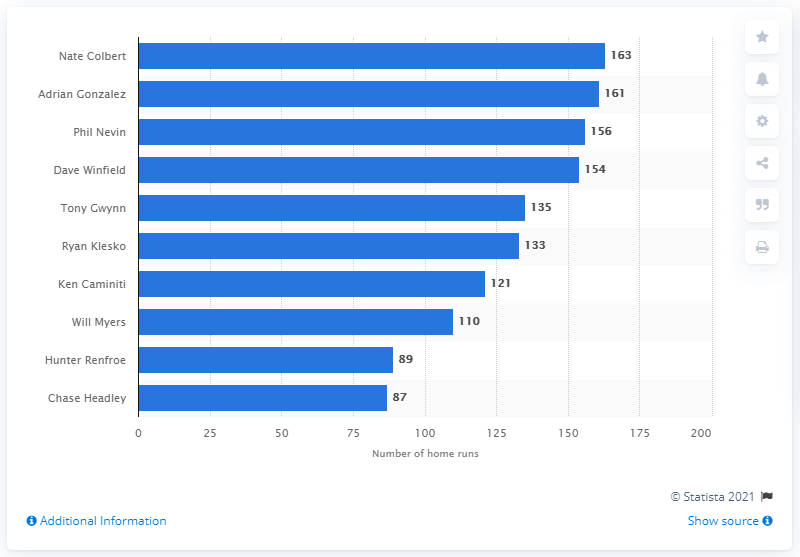Highlight a few significant elements in this photo. The individual who has hit the most home runs in the history of the San Diego Padres franchise is Nate Colbert. Nathan Colbert has hit 163 home runs. 